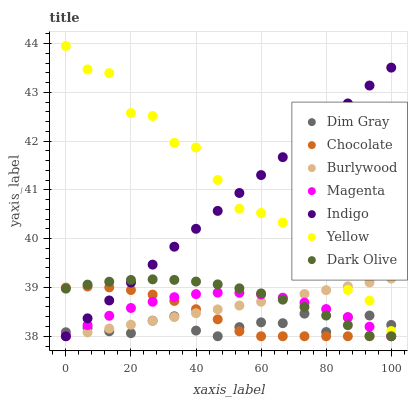Does Dim Gray have the minimum area under the curve?
Answer yes or no. Yes. Does Yellow have the maximum area under the curve?
Answer yes or no. Yes. Does Indigo have the minimum area under the curve?
Answer yes or no. No. Does Indigo have the maximum area under the curve?
Answer yes or no. No. Is Burlywood the smoothest?
Answer yes or no. Yes. Is Yellow the roughest?
Answer yes or no. Yes. Is Indigo the smoothest?
Answer yes or no. No. Is Indigo the roughest?
Answer yes or no. No. Does Dim Gray have the lowest value?
Answer yes or no. Yes. Does Yellow have the lowest value?
Answer yes or no. No. Does Yellow have the highest value?
Answer yes or no. Yes. Does Indigo have the highest value?
Answer yes or no. No. Is Chocolate less than Yellow?
Answer yes or no. Yes. Is Yellow greater than Dark Olive?
Answer yes or no. Yes. Does Dark Olive intersect Dim Gray?
Answer yes or no. Yes. Is Dark Olive less than Dim Gray?
Answer yes or no. No. Is Dark Olive greater than Dim Gray?
Answer yes or no. No. Does Chocolate intersect Yellow?
Answer yes or no. No. 